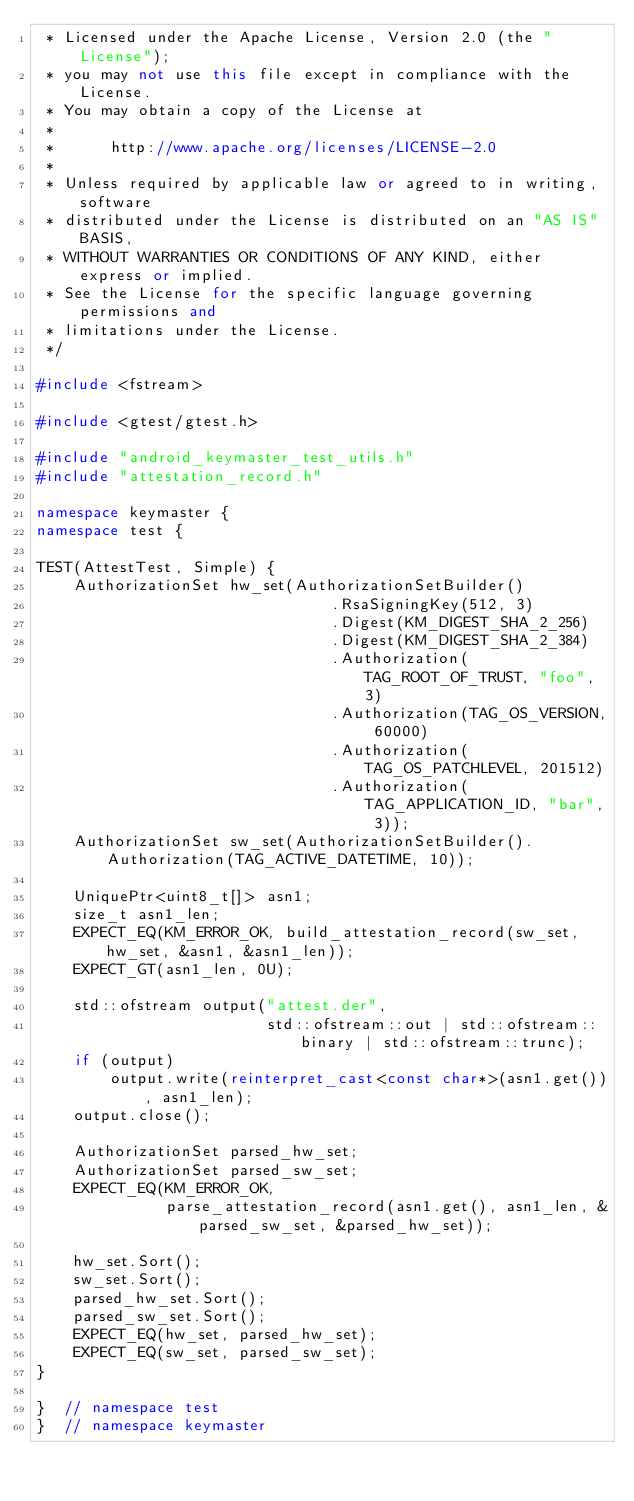Convert code to text. <code><loc_0><loc_0><loc_500><loc_500><_C++_> * Licensed under the Apache License, Version 2.0 (the "License");
 * you may not use this file except in compliance with the License.
 * You may obtain a copy of the License at
 *
 *      http://www.apache.org/licenses/LICENSE-2.0
 *
 * Unless required by applicable law or agreed to in writing, software
 * distributed under the License is distributed on an "AS IS" BASIS,
 * WITHOUT WARRANTIES OR CONDITIONS OF ANY KIND, either express or implied.
 * See the License for the specific language governing permissions and
 * limitations under the License.
 */

#include <fstream>

#include <gtest/gtest.h>

#include "android_keymaster_test_utils.h"
#include "attestation_record.h"

namespace keymaster {
namespace test {

TEST(AttestTest, Simple) {
    AuthorizationSet hw_set(AuthorizationSetBuilder()
                                .RsaSigningKey(512, 3)
                                .Digest(KM_DIGEST_SHA_2_256)
                                .Digest(KM_DIGEST_SHA_2_384)
                                .Authorization(TAG_ROOT_OF_TRUST, "foo", 3)
                                .Authorization(TAG_OS_VERSION, 60000)
                                .Authorization(TAG_OS_PATCHLEVEL, 201512)
                                .Authorization(TAG_APPLICATION_ID, "bar", 3));
    AuthorizationSet sw_set(AuthorizationSetBuilder().Authorization(TAG_ACTIVE_DATETIME, 10));

    UniquePtr<uint8_t[]> asn1;
    size_t asn1_len;
    EXPECT_EQ(KM_ERROR_OK, build_attestation_record(sw_set, hw_set, &asn1, &asn1_len));
    EXPECT_GT(asn1_len, 0U);

    std::ofstream output("attest.der",
                         std::ofstream::out | std::ofstream::binary | std::ofstream::trunc);
    if (output)
        output.write(reinterpret_cast<const char*>(asn1.get()), asn1_len);
    output.close();

    AuthorizationSet parsed_hw_set;
    AuthorizationSet parsed_sw_set;
    EXPECT_EQ(KM_ERROR_OK,
              parse_attestation_record(asn1.get(), asn1_len, &parsed_sw_set, &parsed_hw_set));

    hw_set.Sort();
    sw_set.Sort();
    parsed_hw_set.Sort();
    parsed_sw_set.Sort();
    EXPECT_EQ(hw_set, parsed_hw_set);
    EXPECT_EQ(sw_set, parsed_sw_set);
}

}  // namespace test
}  // namespace keymaster
</code> 